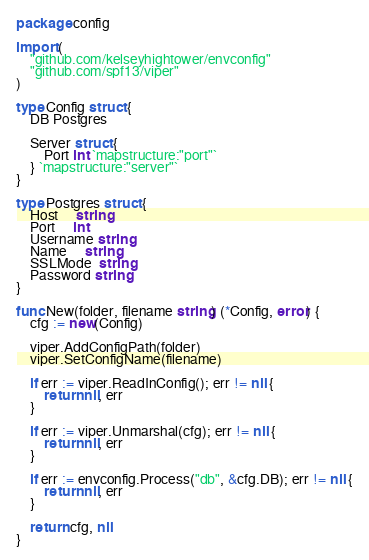Convert code to text. <code><loc_0><loc_0><loc_500><loc_500><_Go_>package config

import (
	"github.com/kelseyhightower/envconfig"
	"github.com/spf13/viper"
)

type Config struct {
	DB Postgres

	Server struct {
		Port int `mapstructure:"port"`
	} `mapstructure:"server"`
}

type Postgres struct {
	Host     string
	Port     int
	Username string
	Name     string
	SSLMode  string
	Password string
}

func New(folder, filename string) (*Config, error) {
	cfg := new(Config)

	viper.AddConfigPath(folder)
	viper.SetConfigName(filename)

	if err := viper.ReadInConfig(); err != nil {
		return nil, err
	}

	if err := viper.Unmarshal(cfg); err != nil {
		return nil, err
	}

	if err := envconfig.Process("db", &cfg.DB); err != nil {
		return nil, err
	}

	return cfg, nil
}
</code> 